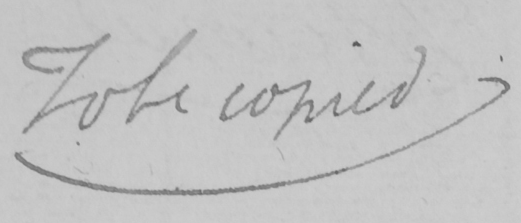Transcribe the text shown in this historical manuscript line. To be copied 